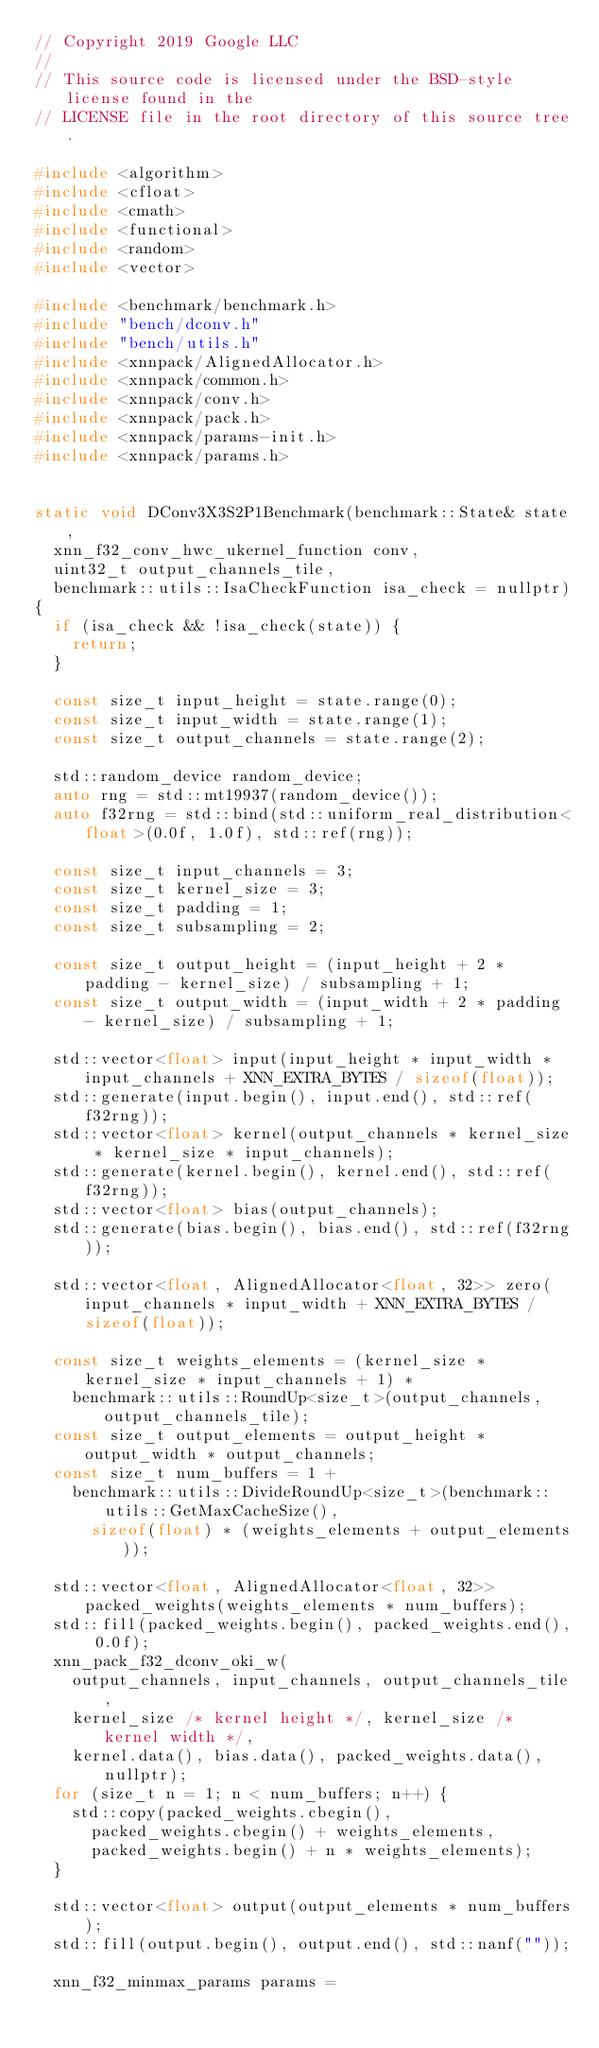<code> <loc_0><loc_0><loc_500><loc_500><_C++_>// Copyright 2019 Google LLC
//
// This source code is licensed under the BSD-style license found in the
// LICENSE file in the root directory of this source tree.

#include <algorithm>
#include <cfloat>
#include <cmath>
#include <functional>
#include <random>
#include <vector>

#include <benchmark/benchmark.h>
#include "bench/dconv.h"
#include "bench/utils.h"
#include <xnnpack/AlignedAllocator.h>
#include <xnnpack/common.h>
#include <xnnpack/conv.h>
#include <xnnpack/pack.h>
#include <xnnpack/params-init.h>
#include <xnnpack/params.h>


static void DConv3X3S2P1Benchmark(benchmark::State& state,
  xnn_f32_conv_hwc_ukernel_function conv,
  uint32_t output_channels_tile,
  benchmark::utils::IsaCheckFunction isa_check = nullptr)
{
  if (isa_check && !isa_check(state)) {
    return;
  }

  const size_t input_height = state.range(0);
  const size_t input_width = state.range(1);
  const size_t output_channels = state.range(2);

  std::random_device random_device;
  auto rng = std::mt19937(random_device());
  auto f32rng = std::bind(std::uniform_real_distribution<float>(0.0f, 1.0f), std::ref(rng));

  const size_t input_channels = 3;
  const size_t kernel_size = 3;
  const size_t padding = 1;
  const size_t subsampling = 2;

  const size_t output_height = (input_height + 2 * padding - kernel_size) / subsampling + 1;
  const size_t output_width = (input_width + 2 * padding - kernel_size) / subsampling + 1;

  std::vector<float> input(input_height * input_width * input_channels + XNN_EXTRA_BYTES / sizeof(float));
  std::generate(input.begin(), input.end(), std::ref(f32rng));
  std::vector<float> kernel(output_channels * kernel_size * kernel_size * input_channels);
  std::generate(kernel.begin(), kernel.end(), std::ref(f32rng));
  std::vector<float> bias(output_channels);
  std::generate(bias.begin(), bias.end(), std::ref(f32rng));

  std::vector<float, AlignedAllocator<float, 32>> zero(input_channels * input_width + XNN_EXTRA_BYTES / sizeof(float));

  const size_t weights_elements = (kernel_size * kernel_size * input_channels + 1) *
    benchmark::utils::RoundUp<size_t>(output_channels, output_channels_tile);
  const size_t output_elements = output_height * output_width * output_channels;
  const size_t num_buffers = 1 +
    benchmark::utils::DivideRoundUp<size_t>(benchmark::utils::GetMaxCacheSize(),
      sizeof(float) * (weights_elements + output_elements));

  std::vector<float, AlignedAllocator<float, 32>> packed_weights(weights_elements * num_buffers);
  std::fill(packed_weights.begin(), packed_weights.end(), 0.0f);
  xnn_pack_f32_dconv_oki_w(
    output_channels, input_channels, output_channels_tile,
    kernel_size /* kernel height */, kernel_size /* kernel width */,
    kernel.data(), bias.data(), packed_weights.data(), nullptr);
  for (size_t n = 1; n < num_buffers; n++) {
    std::copy(packed_weights.cbegin(),
      packed_weights.cbegin() + weights_elements,
      packed_weights.begin() + n * weights_elements);
  }

  std::vector<float> output(output_elements * num_buffers);
  std::fill(output.begin(), output.end(), std::nanf(""));

  xnn_f32_minmax_params params =</code> 